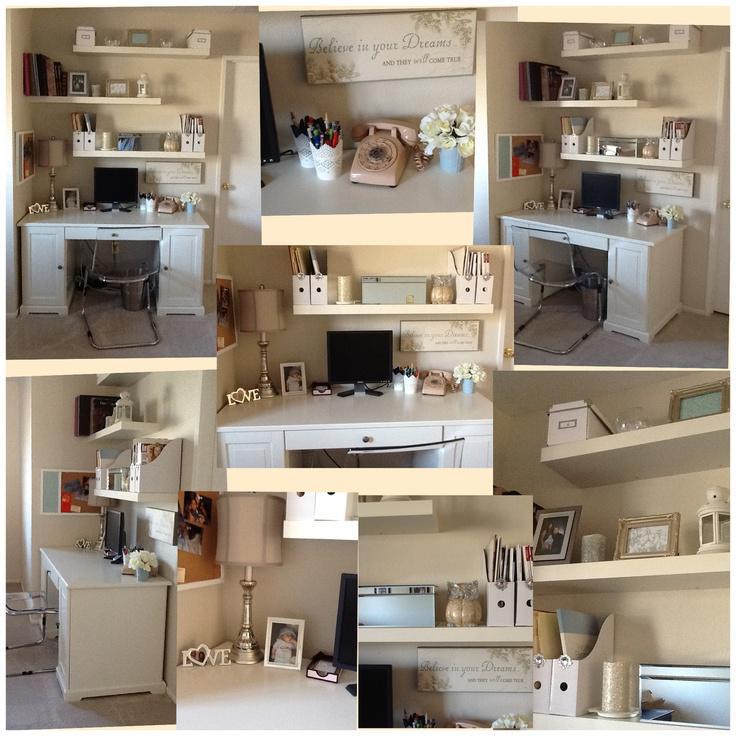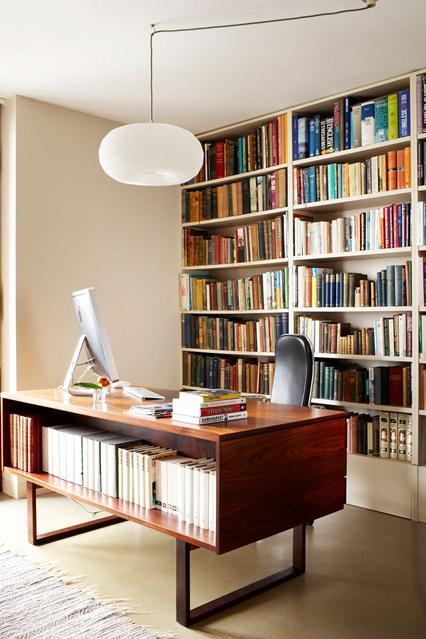The first image is the image on the left, the second image is the image on the right. Assess this claim about the two images: "there is a built in desk and wall shelves with a desk chair at the desk". Correct or not? Answer yes or no. No. The first image is the image on the left, the second image is the image on the right. Analyze the images presented: Is the assertion "In one of the photos, there is a potted plant sitting on a shelf." valid? Answer yes or no. No. 